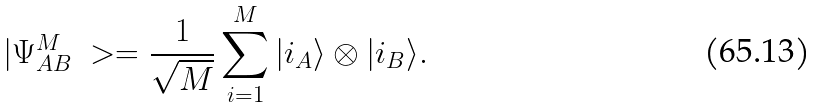<formula> <loc_0><loc_0><loc_500><loc_500>| \Psi ^ { M } _ { A B } \ > = \frac { 1 } { \sqrt { M } } \sum _ { i = 1 } ^ { M } | i _ { A } \rangle \otimes | i _ { B } \rangle .</formula> 